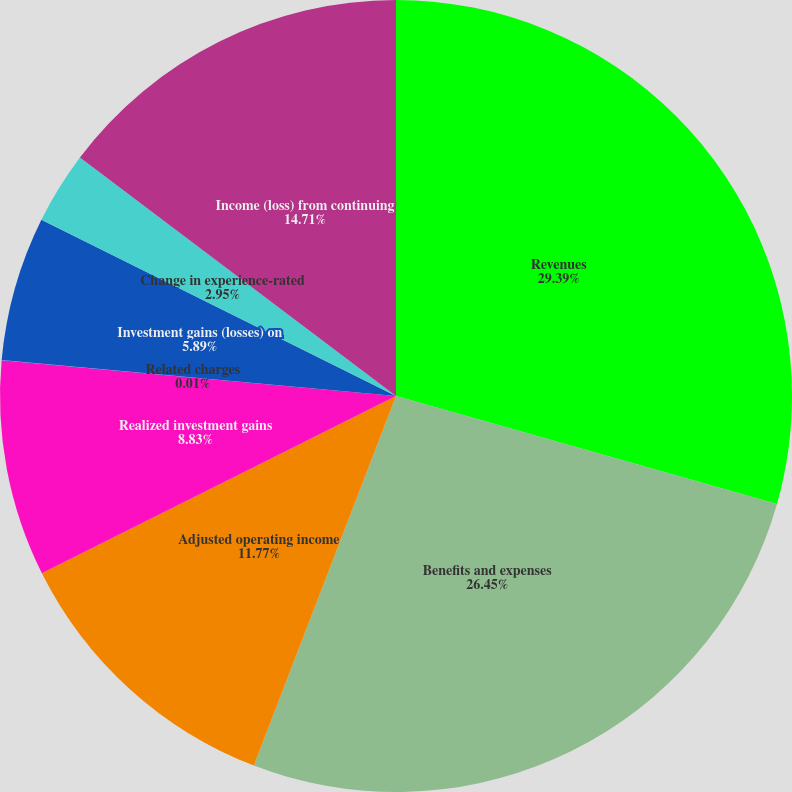Convert chart. <chart><loc_0><loc_0><loc_500><loc_500><pie_chart><fcel>Revenues<fcel>Benefits and expenses<fcel>Adjusted operating income<fcel>Realized investment gains<fcel>Related charges<fcel>Investment gains (losses) on<fcel>Change in experience-rated<fcel>Income (loss) from continuing<nl><fcel>29.4%<fcel>26.45%<fcel>11.77%<fcel>8.83%<fcel>0.01%<fcel>5.89%<fcel>2.95%<fcel>14.71%<nl></chart> 